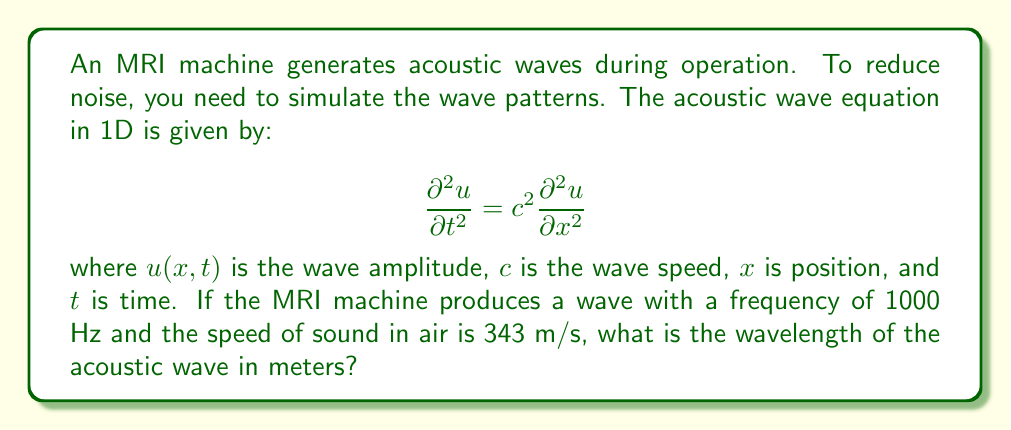Provide a solution to this math problem. To solve this problem, we'll use the wave equation and the relationship between frequency, wavelength, and wave speed. Let's proceed step-by-step:

1) The general relationship between frequency ($f$), wavelength ($\lambda$), and wave speed ($c$) is:

   $$c = f \lambda$$

2) We are given:
   - Frequency, $f = 1000$ Hz
   - Speed of sound in air, $c = 343$ m/s

3) Rearranging the equation to solve for wavelength:

   $$\lambda = \frac{c}{f}$$

4) Substituting the known values:

   $$\lambda = \frac{343 \text{ m/s}}{1000 \text{ Hz}}$$

5) Simplifying:

   $$\lambda = 0.343 \text{ m}$$

Therefore, the wavelength of the acoustic wave is 0.343 meters.
Answer: 0.343 m 